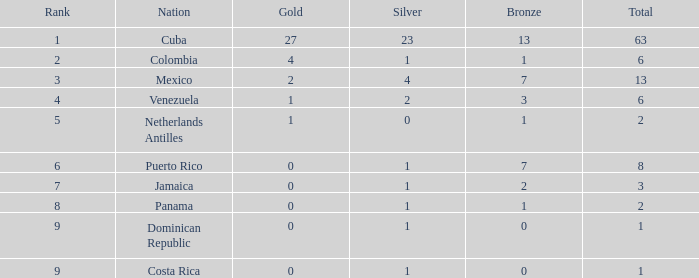In countries ranked higher than 9, which one has the least average gold quantity? None. 